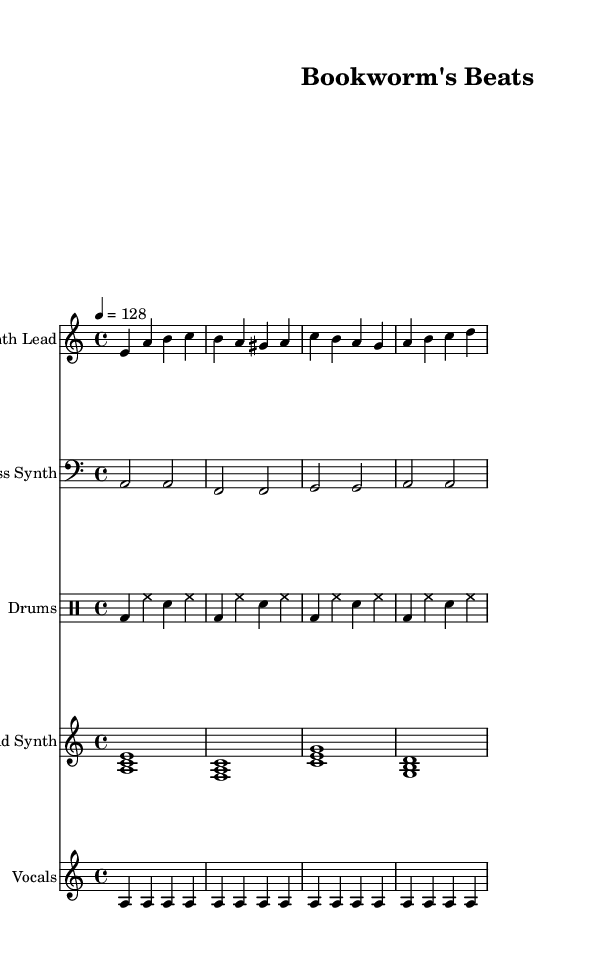What is the key signature of this music? The key signature is A minor, which contains no sharps or flats, indicated by the "a" in the "key" declaration in the global block.
Answer: A minor What is the time signature of this music? The time signature is 4/4, denoting four beats per measure and the quarter note as the beat, indicated by the "time" declaration in the global block.
Answer: 4/4 What is the tempo of this piece? The tempo is set at 128 beats per minute, indicated by "tempo 4 = 128" in the global block, which suggests the speed at which the piece should be played.
Answer: 128 How many measures are in the synth lead section? The synth lead section consists of four measures, as indicated by the four bars represented in the synth lead part of the score.
Answer: 4 What instrument plays the bass line? The bass line is played by the bass synth, as indicated by the instrument name specified in the corresponding staff.
Answer: Bass Synth What do the vocals primarily convey in this piece? The vocals convey a literary theme, specifically referencing reading and rhythm through the lyrics, evident in the text aligned with the vocal staff.
Answer: Literary theme Which sections of the music have lyrics? The lyrics are aligned with the vocals section, as indicated in the score where the "Lyrics" staff is indicated to correspond with the "vocals" part.
Answer: Vocals 